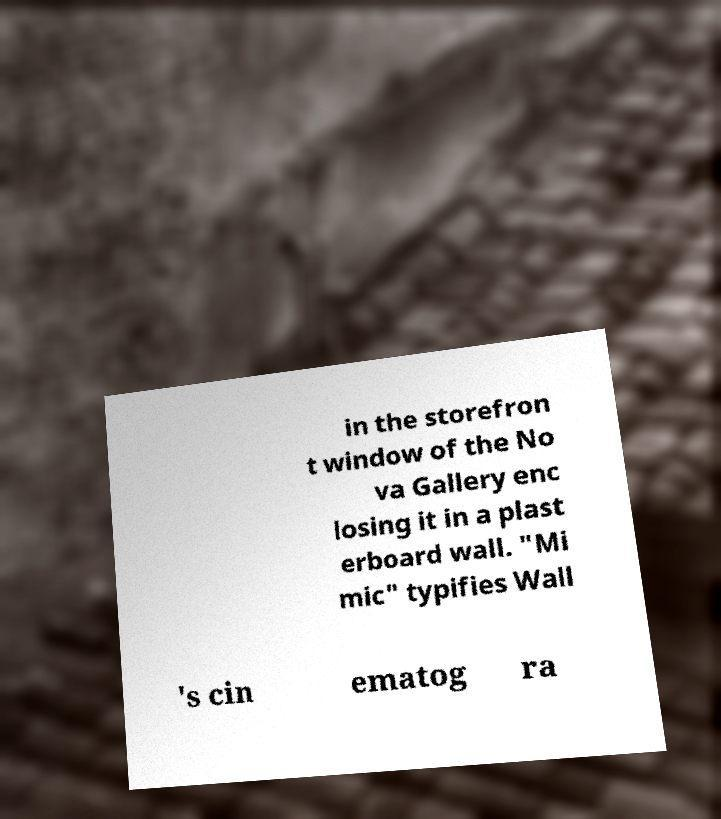Can you read and provide the text displayed in the image?This photo seems to have some interesting text. Can you extract and type it out for me? in the storefron t window of the No va Gallery enc losing it in a plast erboard wall. "Mi mic" typifies Wall 's cin ematog ra 